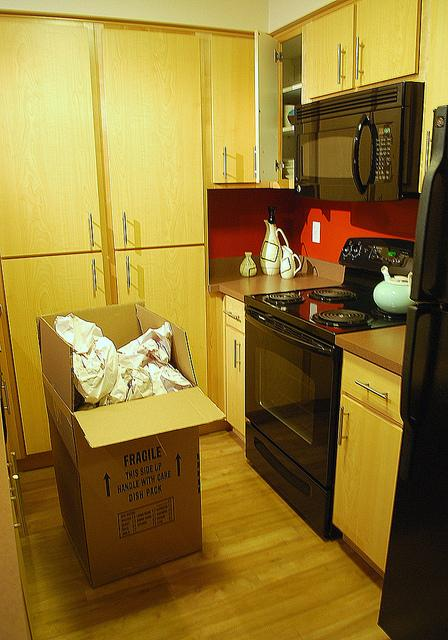What is the top word on the box?

Choices:
A) caution
B) waste
C) lift
D) fragile fragile 